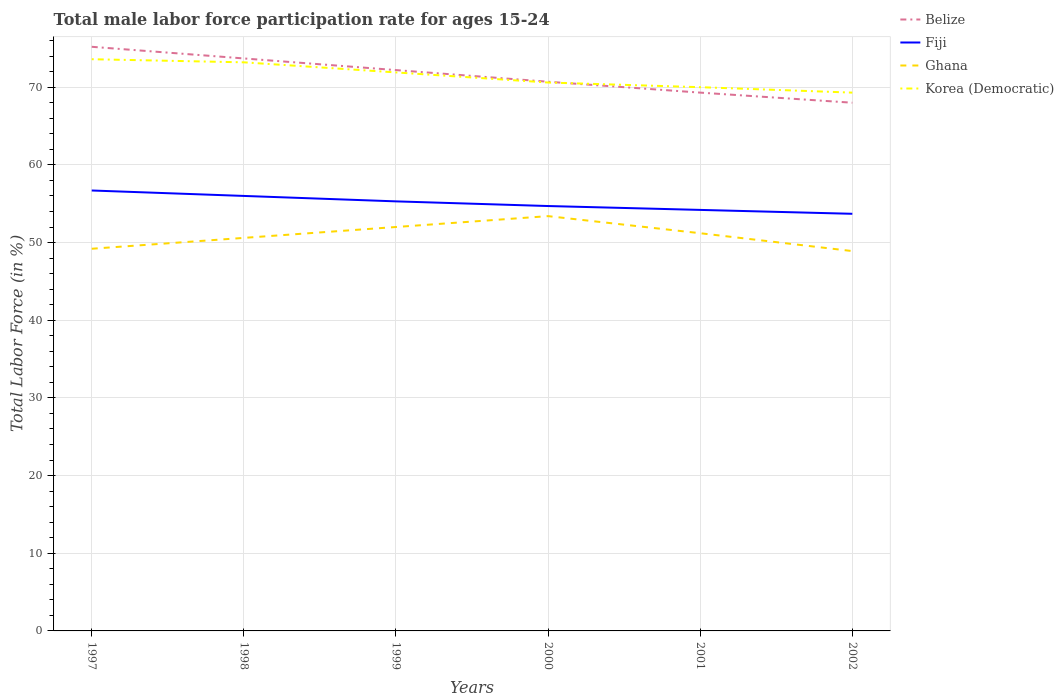How many different coloured lines are there?
Make the answer very short. 4. Does the line corresponding to Ghana intersect with the line corresponding to Fiji?
Your answer should be very brief. No. Across all years, what is the maximum male labor force participation rate in Belize?
Keep it short and to the point. 68. What is the total male labor force participation rate in Fiji in the graph?
Your answer should be very brief. 2. What is the difference between the highest and the lowest male labor force participation rate in Fiji?
Your answer should be very brief. 3. Is the male labor force participation rate in Belize strictly greater than the male labor force participation rate in Korea (Democratic) over the years?
Offer a terse response. No. What is the difference between two consecutive major ticks on the Y-axis?
Keep it short and to the point. 10. Are the values on the major ticks of Y-axis written in scientific E-notation?
Provide a short and direct response. No. Does the graph contain any zero values?
Give a very brief answer. No. Does the graph contain grids?
Make the answer very short. Yes. How many legend labels are there?
Provide a short and direct response. 4. What is the title of the graph?
Offer a terse response. Total male labor force participation rate for ages 15-24. Does "Slovak Republic" appear as one of the legend labels in the graph?
Your response must be concise. No. What is the label or title of the X-axis?
Ensure brevity in your answer.  Years. What is the Total Labor Force (in %) of Belize in 1997?
Provide a short and direct response. 75.2. What is the Total Labor Force (in %) of Fiji in 1997?
Your answer should be very brief. 56.7. What is the Total Labor Force (in %) of Ghana in 1997?
Make the answer very short. 49.2. What is the Total Labor Force (in %) of Korea (Democratic) in 1997?
Your response must be concise. 73.6. What is the Total Labor Force (in %) in Belize in 1998?
Your response must be concise. 73.7. What is the Total Labor Force (in %) in Fiji in 1998?
Your answer should be compact. 56. What is the Total Labor Force (in %) in Ghana in 1998?
Offer a terse response. 50.6. What is the Total Labor Force (in %) in Korea (Democratic) in 1998?
Your answer should be compact. 73.2. What is the Total Labor Force (in %) in Belize in 1999?
Ensure brevity in your answer.  72.2. What is the Total Labor Force (in %) in Fiji in 1999?
Your answer should be compact. 55.3. What is the Total Labor Force (in %) in Ghana in 1999?
Offer a very short reply. 52. What is the Total Labor Force (in %) of Korea (Democratic) in 1999?
Keep it short and to the point. 71.9. What is the Total Labor Force (in %) in Belize in 2000?
Provide a succinct answer. 70.7. What is the Total Labor Force (in %) of Fiji in 2000?
Give a very brief answer. 54.7. What is the Total Labor Force (in %) in Ghana in 2000?
Your response must be concise. 53.4. What is the Total Labor Force (in %) of Korea (Democratic) in 2000?
Ensure brevity in your answer.  70.6. What is the Total Labor Force (in %) in Belize in 2001?
Your answer should be very brief. 69.3. What is the Total Labor Force (in %) of Fiji in 2001?
Provide a succinct answer. 54.2. What is the Total Labor Force (in %) of Ghana in 2001?
Keep it short and to the point. 51.2. What is the Total Labor Force (in %) of Fiji in 2002?
Your answer should be compact. 53.7. What is the Total Labor Force (in %) in Ghana in 2002?
Your response must be concise. 48.9. What is the Total Labor Force (in %) of Korea (Democratic) in 2002?
Keep it short and to the point. 69.3. Across all years, what is the maximum Total Labor Force (in %) in Belize?
Your answer should be very brief. 75.2. Across all years, what is the maximum Total Labor Force (in %) of Fiji?
Provide a succinct answer. 56.7. Across all years, what is the maximum Total Labor Force (in %) of Ghana?
Offer a very short reply. 53.4. Across all years, what is the maximum Total Labor Force (in %) of Korea (Democratic)?
Keep it short and to the point. 73.6. Across all years, what is the minimum Total Labor Force (in %) of Belize?
Offer a terse response. 68. Across all years, what is the minimum Total Labor Force (in %) in Fiji?
Your response must be concise. 53.7. Across all years, what is the minimum Total Labor Force (in %) in Ghana?
Make the answer very short. 48.9. Across all years, what is the minimum Total Labor Force (in %) in Korea (Democratic)?
Give a very brief answer. 69.3. What is the total Total Labor Force (in %) in Belize in the graph?
Keep it short and to the point. 429.1. What is the total Total Labor Force (in %) of Fiji in the graph?
Provide a short and direct response. 330.6. What is the total Total Labor Force (in %) in Ghana in the graph?
Your response must be concise. 305.3. What is the total Total Labor Force (in %) of Korea (Democratic) in the graph?
Provide a short and direct response. 428.6. What is the difference between the Total Labor Force (in %) in Belize in 1997 and that in 1998?
Your answer should be very brief. 1.5. What is the difference between the Total Labor Force (in %) of Ghana in 1997 and that in 1998?
Provide a succinct answer. -1.4. What is the difference between the Total Labor Force (in %) of Korea (Democratic) in 1997 and that in 1999?
Give a very brief answer. 1.7. What is the difference between the Total Labor Force (in %) in Belize in 1997 and that in 2000?
Your answer should be very brief. 4.5. What is the difference between the Total Labor Force (in %) of Fiji in 1997 and that in 2000?
Keep it short and to the point. 2. What is the difference between the Total Labor Force (in %) in Ghana in 1997 and that in 2000?
Provide a succinct answer. -4.2. What is the difference between the Total Labor Force (in %) of Korea (Democratic) in 1997 and that in 2000?
Your answer should be very brief. 3. What is the difference between the Total Labor Force (in %) in Belize in 1997 and that in 2001?
Ensure brevity in your answer.  5.9. What is the difference between the Total Labor Force (in %) of Fiji in 1997 and that in 2001?
Provide a succinct answer. 2.5. What is the difference between the Total Labor Force (in %) of Belize in 1997 and that in 2002?
Your response must be concise. 7.2. What is the difference between the Total Labor Force (in %) of Ghana in 1997 and that in 2002?
Provide a succinct answer. 0.3. What is the difference between the Total Labor Force (in %) in Belize in 1998 and that in 2000?
Make the answer very short. 3. What is the difference between the Total Labor Force (in %) in Fiji in 1998 and that in 2000?
Provide a short and direct response. 1.3. What is the difference between the Total Labor Force (in %) of Korea (Democratic) in 1998 and that in 2000?
Your answer should be compact. 2.6. What is the difference between the Total Labor Force (in %) of Belize in 1998 and that in 2002?
Make the answer very short. 5.7. What is the difference between the Total Labor Force (in %) in Ghana in 1998 and that in 2002?
Provide a short and direct response. 1.7. What is the difference between the Total Labor Force (in %) of Korea (Democratic) in 1998 and that in 2002?
Ensure brevity in your answer.  3.9. What is the difference between the Total Labor Force (in %) of Belize in 1999 and that in 2000?
Give a very brief answer. 1.5. What is the difference between the Total Labor Force (in %) of Korea (Democratic) in 1999 and that in 2000?
Offer a very short reply. 1.3. What is the difference between the Total Labor Force (in %) in Ghana in 1999 and that in 2001?
Your answer should be very brief. 0.8. What is the difference between the Total Labor Force (in %) of Korea (Democratic) in 1999 and that in 2001?
Keep it short and to the point. 1.9. What is the difference between the Total Labor Force (in %) of Ghana in 2000 and that in 2001?
Provide a succinct answer. 2.2. What is the difference between the Total Labor Force (in %) of Korea (Democratic) in 2000 and that in 2001?
Your answer should be very brief. 0.6. What is the difference between the Total Labor Force (in %) of Belize in 2000 and that in 2002?
Offer a very short reply. 2.7. What is the difference between the Total Labor Force (in %) in Ghana in 2000 and that in 2002?
Make the answer very short. 4.5. What is the difference between the Total Labor Force (in %) of Belize in 2001 and that in 2002?
Keep it short and to the point. 1.3. What is the difference between the Total Labor Force (in %) in Fiji in 2001 and that in 2002?
Provide a succinct answer. 0.5. What is the difference between the Total Labor Force (in %) in Belize in 1997 and the Total Labor Force (in %) in Fiji in 1998?
Your answer should be compact. 19.2. What is the difference between the Total Labor Force (in %) in Belize in 1997 and the Total Labor Force (in %) in Ghana in 1998?
Give a very brief answer. 24.6. What is the difference between the Total Labor Force (in %) in Belize in 1997 and the Total Labor Force (in %) in Korea (Democratic) in 1998?
Offer a very short reply. 2. What is the difference between the Total Labor Force (in %) of Fiji in 1997 and the Total Labor Force (in %) of Ghana in 1998?
Keep it short and to the point. 6.1. What is the difference between the Total Labor Force (in %) in Fiji in 1997 and the Total Labor Force (in %) in Korea (Democratic) in 1998?
Give a very brief answer. -16.5. What is the difference between the Total Labor Force (in %) of Belize in 1997 and the Total Labor Force (in %) of Fiji in 1999?
Offer a very short reply. 19.9. What is the difference between the Total Labor Force (in %) of Belize in 1997 and the Total Labor Force (in %) of Ghana in 1999?
Ensure brevity in your answer.  23.2. What is the difference between the Total Labor Force (in %) of Belize in 1997 and the Total Labor Force (in %) of Korea (Democratic) in 1999?
Your response must be concise. 3.3. What is the difference between the Total Labor Force (in %) of Fiji in 1997 and the Total Labor Force (in %) of Ghana in 1999?
Provide a short and direct response. 4.7. What is the difference between the Total Labor Force (in %) of Fiji in 1997 and the Total Labor Force (in %) of Korea (Democratic) in 1999?
Provide a succinct answer. -15.2. What is the difference between the Total Labor Force (in %) of Ghana in 1997 and the Total Labor Force (in %) of Korea (Democratic) in 1999?
Give a very brief answer. -22.7. What is the difference between the Total Labor Force (in %) of Belize in 1997 and the Total Labor Force (in %) of Ghana in 2000?
Your response must be concise. 21.8. What is the difference between the Total Labor Force (in %) in Ghana in 1997 and the Total Labor Force (in %) in Korea (Democratic) in 2000?
Provide a succinct answer. -21.4. What is the difference between the Total Labor Force (in %) in Belize in 1997 and the Total Labor Force (in %) in Ghana in 2001?
Your answer should be compact. 24. What is the difference between the Total Labor Force (in %) in Belize in 1997 and the Total Labor Force (in %) in Korea (Democratic) in 2001?
Keep it short and to the point. 5.2. What is the difference between the Total Labor Force (in %) in Fiji in 1997 and the Total Labor Force (in %) in Ghana in 2001?
Your answer should be compact. 5.5. What is the difference between the Total Labor Force (in %) of Ghana in 1997 and the Total Labor Force (in %) of Korea (Democratic) in 2001?
Ensure brevity in your answer.  -20.8. What is the difference between the Total Labor Force (in %) of Belize in 1997 and the Total Labor Force (in %) of Ghana in 2002?
Provide a succinct answer. 26.3. What is the difference between the Total Labor Force (in %) in Belize in 1997 and the Total Labor Force (in %) in Korea (Democratic) in 2002?
Your answer should be very brief. 5.9. What is the difference between the Total Labor Force (in %) of Fiji in 1997 and the Total Labor Force (in %) of Ghana in 2002?
Offer a terse response. 7.8. What is the difference between the Total Labor Force (in %) of Fiji in 1997 and the Total Labor Force (in %) of Korea (Democratic) in 2002?
Make the answer very short. -12.6. What is the difference between the Total Labor Force (in %) in Ghana in 1997 and the Total Labor Force (in %) in Korea (Democratic) in 2002?
Offer a terse response. -20.1. What is the difference between the Total Labor Force (in %) of Belize in 1998 and the Total Labor Force (in %) of Fiji in 1999?
Give a very brief answer. 18.4. What is the difference between the Total Labor Force (in %) in Belize in 1998 and the Total Labor Force (in %) in Ghana in 1999?
Your response must be concise. 21.7. What is the difference between the Total Labor Force (in %) in Fiji in 1998 and the Total Labor Force (in %) in Ghana in 1999?
Your answer should be very brief. 4. What is the difference between the Total Labor Force (in %) of Fiji in 1998 and the Total Labor Force (in %) of Korea (Democratic) in 1999?
Offer a very short reply. -15.9. What is the difference between the Total Labor Force (in %) in Ghana in 1998 and the Total Labor Force (in %) in Korea (Democratic) in 1999?
Your answer should be very brief. -21.3. What is the difference between the Total Labor Force (in %) of Belize in 1998 and the Total Labor Force (in %) of Fiji in 2000?
Offer a very short reply. 19. What is the difference between the Total Labor Force (in %) in Belize in 1998 and the Total Labor Force (in %) in Ghana in 2000?
Make the answer very short. 20.3. What is the difference between the Total Labor Force (in %) of Fiji in 1998 and the Total Labor Force (in %) of Ghana in 2000?
Give a very brief answer. 2.6. What is the difference between the Total Labor Force (in %) of Fiji in 1998 and the Total Labor Force (in %) of Korea (Democratic) in 2000?
Give a very brief answer. -14.6. What is the difference between the Total Labor Force (in %) of Belize in 1998 and the Total Labor Force (in %) of Korea (Democratic) in 2001?
Keep it short and to the point. 3.7. What is the difference between the Total Labor Force (in %) in Fiji in 1998 and the Total Labor Force (in %) in Ghana in 2001?
Make the answer very short. 4.8. What is the difference between the Total Labor Force (in %) in Fiji in 1998 and the Total Labor Force (in %) in Korea (Democratic) in 2001?
Give a very brief answer. -14. What is the difference between the Total Labor Force (in %) of Ghana in 1998 and the Total Labor Force (in %) of Korea (Democratic) in 2001?
Offer a very short reply. -19.4. What is the difference between the Total Labor Force (in %) of Belize in 1998 and the Total Labor Force (in %) of Fiji in 2002?
Give a very brief answer. 20. What is the difference between the Total Labor Force (in %) in Belize in 1998 and the Total Labor Force (in %) in Ghana in 2002?
Make the answer very short. 24.8. What is the difference between the Total Labor Force (in %) in Ghana in 1998 and the Total Labor Force (in %) in Korea (Democratic) in 2002?
Your response must be concise. -18.7. What is the difference between the Total Labor Force (in %) of Belize in 1999 and the Total Labor Force (in %) of Fiji in 2000?
Make the answer very short. 17.5. What is the difference between the Total Labor Force (in %) in Belize in 1999 and the Total Labor Force (in %) in Ghana in 2000?
Give a very brief answer. 18.8. What is the difference between the Total Labor Force (in %) of Belize in 1999 and the Total Labor Force (in %) of Korea (Democratic) in 2000?
Provide a short and direct response. 1.6. What is the difference between the Total Labor Force (in %) of Fiji in 1999 and the Total Labor Force (in %) of Ghana in 2000?
Provide a short and direct response. 1.9. What is the difference between the Total Labor Force (in %) of Fiji in 1999 and the Total Labor Force (in %) of Korea (Democratic) in 2000?
Make the answer very short. -15.3. What is the difference between the Total Labor Force (in %) in Ghana in 1999 and the Total Labor Force (in %) in Korea (Democratic) in 2000?
Make the answer very short. -18.6. What is the difference between the Total Labor Force (in %) in Belize in 1999 and the Total Labor Force (in %) in Korea (Democratic) in 2001?
Keep it short and to the point. 2.2. What is the difference between the Total Labor Force (in %) of Fiji in 1999 and the Total Labor Force (in %) of Ghana in 2001?
Offer a terse response. 4.1. What is the difference between the Total Labor Force (in %) of Fiji in 1999 and the Total Labor Force (in %) of Korea (Democratic) in 2001?
Make the answer very short. -14.7. What is the difference between the Total Labor Force (in %) of Belize in 1999 and the Total Labor Force (in %) of Fiji in 2002?
Keep it short and to the point. 18.5. What is the difference between the Total Labor Force (in %) in Belize in 1999 and the Total Labor Force (in %) in Ghana in 2002?
Keep it short and to the point. 23.3. What is the difference between the Total Labor Force (in %) in Belize in 1999 and the Total Labor Force (in %) in Korea (Democratic) in 2002?
Make the answer very short. 2.9. What is the difference between the Total Labor Force (in %) of Fiji in 1999 and the Total Labor Force (in %) of Ghana in 2002?
Offer a very short reply. 6.4. What is the difference between the Total Labor Force (in %) in Ghana in 1999 and the Total Labor Force (in %) in Korea (Democratic) in 2002?
Make the answer very short. -17.3. What is the difference between the Total Labor Force (in %) in Belize in 2000 and the Total Labor Force (in %) in Fiji in 2001?
Your answer should be compact. 16.5. What is the difference between the Total Labor Force (in %) in Fiji in 2000 and the Total Labor Force (in %) in Korea (Democratic) in 2001?
Your answer should be compact. -15.3. What is the difference between the Total Labor Force (in %) in Ghana in 2000 and the Total Labor Force (in %) in Korea (Democratic) in 2001?
Your response must be concise. -16.6. What is the difference between the Total Labor Force (in %) of Belize in 2000 and the Total Labor Force (in %) of Ghana in 2002?
Keep it short and to the point. 21.8. What is the difference between the Total Labor Force (in %) of Fiji in 2000 and the Total Labor Force (in %) of Ghana in 2002?
Keep it short and to the point. 5.8. What is the difference between the Total Labor Force (in %) of Fiji in 2000 and the Total Labor Force (in %) of Korea (Democratic) in 2002?
Your answer should be compact. -14.6. What is the difference between the Total Labor Force (in %) in Ghana in 2000 and the Total Labor Force (in %) in Korea (Democratic) in 2002?
Your response must be concise. -15.9. What is the difference between the Total Labor Force (in %) in Belize in 2001 and the Total Labor Force (in %) in Ghana in 2002?
Keep it short and to the point. 20.4. What is the difference between the Total Labor Force (in %) of Fiji in 2001 and the Total Labor Force (in %) of Ghana in 2002?
Provide a succinct answer. 5.3. What is the difference between the Total Labor Force (in %) in Fiji in 2001 and the Total Labor Force (in %) in Korea (Democratic) in 2002?
Keep it short and to the point. -15.1. What is the difference between the Total Labor Force (in %) of Ghana in 2001 and the Total Labor Force (in %) of Korea (Democratic) in 2002?
Provide a short and direct response. -18.1. What is the average Total Labor Force (in %) in Belize per year?
Ensure brevity in your answer.  71.52. What is the average Total Labor Force (in %) of Fiji per year?
Offer a very short reply. 55.1. What is the average Total Labor Force (in %) in Ghana per year?
Ensure brevity in your answer.  50.88. What is the average Total Labor Force (in %) of Korea (Democratic) per year?
Your answer should be very brief. 71.43. In the year 1997, what is the difference between the Total Labor Force (in %) in Belize and Total Labor Force (in %) in Fiji?
Offer a terse response. 18.5. In the year 1997, what is the difference between the Total Labor Force (in %) of Belize and Total Labor Force (in %) of Ghana?
Offer a very short reply. 26. In the year 1997, what is the difference between the Total Labor Force (in %) in Belize and Total Labor Force (in %) in Korea (Democratic)?
Provide a short and direct response. 1.6. In the year 1997, what is the difference between the Total Labor Force (in %) in Fiji and Total Labor Force (in %) in Korea (Democratic)?
Ensure brevity in your answer.  -16.9. In the year 1997, what is the difference between the Total Labor Force (in %) in Ghana and Total Labor Force (in %) in Korea (Democratic)?
Ensure brevity in your answer.  -24.4. In the year 1998, what is the difference between the Total Labor Force (in %) in Belize and Total Labor Force (in %) in Fiji?
Offer a very short reply. 17.7. In the year 1998, what is the difference between the Total Labor Force (in %) of Belize and Total Labor Force (in %) of Ghana?
Keep it short and to the point. 23.1. In the year 1998, what is the difference between the Total Labor Force (in %) in Fiji and Total Labor Force (in %) in Ghana?
Give a very brief answer. 5.4. In the year 1998, what is the difference between the Total Labor Force (in %) in Fiji and Total Labor Force (in %) in Korea (Democratic)?
Your response must be concise. -17.2. In the year 1998, what is the difference between the Total Labor Force (in %) of Ghana and Total Labor Force (in %) of Korea (Democratic)?
Offer a terse response. -22.6. In the year 1999, what is the difference between the Total Labor Force (in %) of Belize and Total Labor Force (in %) of Ghana?
Offer a terse response. 20.2. In the year 1999, what is the difference between the Total Labor Force (in %) in Fiji and Total Labor Force (in %) in Korea (Democratic)?
Give a very brief answer. -16.6. In the year 1999, what is the difference between the Total Labor Force (in %) in Ghana and Total Labor Force (in %) in Korea (Democratic)?
Provide a short and direct response. -19.9. In the year 2000, what is the difference between the Total Labor Force (in %) of Belize and Total Labor Force (in %) of Fiji?
Offer a terse response. 16. In the year 2000, what is the difference between the Total Labor Force (in %) in Fiji and Total Labor Force (in %) in Korea (Democratic)?
Your response must be concise. -15.9. In the year 2000, what is the difference between the Total Labor Force (in %) of Ghana and Total Labor Force (in %) of Korea (Democratic)?
Your answer should be very brief. -17.2. In the year 2001, what is the difference between the Total Labor Force (in %) in Belize and Total Labor Force (in %) in Fiji?
Make the answer very short. 15.1. In the year 2001, what is the difference between the Total Labor Force (in %) of Belize and Total Labor Force (in %) of Ghana?
Offer a very short reply. 18.1. In the year 2001, what is the difference between the Total Labor Force (in %) in Belize and Total Labor Force (in %) in Korea (Democratic)?
Offer a terse response. -0.7. In the year 2001, what is the difference between the Total Labor Force (in %) of Fiji and Total Labor Force (in %) of Ghana?
Your response must be concise. 3. In the year 2001, what is the difference between the Total Labor Force (in %) of Fiji and Total Labor Force (in %) of Korea (Democratic)?
Ensure brevity in your answer.  -15.8. In the year 2001, what is the difference between the Total Labor Force (in %) of Ghana and Total Labor Force (in %) of Korea (Democratic)?
Provide a short and direct response. -18.8. In the year 2002, what is the difference between the Total Labor Force (in %) in Belize and Total Labor Force (in %) in Ghana?
Offer a terse response. 19.1. In the year 2002, what is the difference between the Total Labor Force (in %) in Belize and Total Labor Force (in %) in Korea (Democratic)?
Your answer should be compact. -1.3. In the year 2002, what is the difference between the Total Labor Force (in %) in Fiji and Total Labor Force (in %) in Korea (Democratic)?
Offer a very short reply. -15.6. In the year 2002, what is the difference between the Total Labor Force (in %) of Ghana and Total Labor Force (in %) of Korea (Democratic)?
Offer a terse response. -20.4. What is the ratio of the Total Labor Force (in %) in Belize in 1997 to that in 1998?
Ensure brevity in your answer.  1.02. What is the ratio of the Total Labor Force (in %) of Fiji in 1997 to that in 1998?
Give a very brief answer. 1.01. What is the ratio of the Total Labor Force (in %) of Ghana in 1997 to that in 1998?
Offer a terse response. 0.97. What is the ratio of the Total Labor Force (in %) in Belize in 1997 to that in 1999?
Give a very brief answer. 1.04. What is the ratio of the Total Labor Force (in %) of Fiji in 1997 to that in 1999?
Your answer should be very brief. 1.03. What is the ratio of the Total Labor Force (in %) in Ghana in 1997 to that in 1999?
Make the answer very short. 0.95. What is the ratio of the Total Labor Force (in %) of Korea (Democratic) in 1997 to that in 1999?
Provide a succinct answer. 1.02. What is the ratio of the Total Labor Force (in %) of Belize in 1997 to that in 2000?
Make the answer very short. 1.06. What is the ratio of the Total Labor Force (in %) of Fiji in 1997 to that in 2000?
Keep it short and to the point. 1.04. What is the ratio of the Total Labor Force (in %) of Ghana in 1997 to that in 2000?
Offer a very short reply. 0.92. What is the ratio of the Total Labor Force (in %) in Korea (Democratic) in 1997 to that in 2000?
Keep it short and to the point. 1.04. What is the ratio of the Total Labor Force (in %) of Belize in 1997 to that in 2001?
Offer a terse response. 1.09. What is the ratio of the Total Labor Force (in %) of Fiji in 1997 to that in 2001?
Make the answer very short. 1.05. What is the ratio of the Total Labor Force (in %) of Ghana in 1997 to that in 2001?
Your answer should be compact. 0.96. What is the ratio of the Total Labor Force (in %) of Korea (Democratic) in 1997 to that in 2001?
Your answer should be very brief. 1.05. What is the ratio of the Total Labor Force (in %) of Belize in 1997 to that in 2002?
Provide a short and direct response. 1.11. What is the ratio of the Total Labor Force (in %) in Fiji in 1997 to that in 2002?
Offer a very short reply. 1.06. What is the ratio of the Total Labor Force (in %) of Korea (Democratic) in 1997 to that in 2002?
Keep it short and to the point. 1.06. What is the ratio of the Total Labor Force (in %) in Belize in 1998 to that in 1999?
Provide a short and direct response. 1.02. What is the ratio of the Total Labor Force (in %) in Fiji in 1998 to that in 1999?
Keep it short and to the point. 1.01. What is the ratio of the Total Labor Force (in %) of Ghana in 1998 to that in 1999?
Your answer should be compact. 0.97. What is the ratio of the Total Labor Force (in %) of Korea (Democratic) in 1998 to that in 1999?
Your answer should be compact. 1.02. What is the ratio of the Total Labor Force (in %) of Belize in 1998 to that in 2000?
Offer a terse response. 1.04. What is the ratio of the Total Labor Force (in %) of Fiji in 1998 to that in 2000?
Keep it short and to the point. 1.02. What is the ratio of the Total Labor Force (in %) of Ghana in 1998 to that in 2000?
Offer a very short reply. 0.95. What is the ratio of the Total Labor Force (in %) of Korea (Democratic) in 1998 to that in 2000?
Offer a very short reply. 1.04. What is the ratio of the Total Labor Force (in %) of Belize in 1998 to that in 2001?
Your answer should be very brief. 1.06. What is the ratio of the Total Labor Force (in %) in Fiji in 1998 to that in 2001?
Your answer should be compact. 1.03. What is the ratio of the Total Labor Force (in %) of Ghana in 1998 to that in 2001?
Your response must be concise. 0.99. What is the ratio of the Total Labor Force (in %) of Korea (Democratic) in 1998 to that in 2001?
Offer a terse response. 1.05. What is the ratio of the Total Labor Force (in %) in Belize in 1998 to that in 2002?
Your answer should be compact. 1.08. What is the ratio of the Total Labor Force (in %) of Fiji in 1998 to that in 2002?
Keep it short and to the point. 1.04. What is the ratio of the Total Labor Force (in %) of Ghana in 1998 to that in 2002?
Provide a succinct answer. 1.03. What is the ratio of the Total Labor Force (in %) of Korea (Democratic) in 1998 to that in 2002?
Provide a short and direct response. 1.06. What is the ratio of the Total Labor Force (in %) in Belize in 1999 to that in 2000?
Ensure brevity in your answer.  1.02. What is the ratio of the Total Labor Force (in %) in Fiji in 1999 to that in 2000?
Provide a short and direct response. 1.01. What is the ratio of the Total Labor Force (in %) in Ghana in 1999 to that in 2000?
Your answer should be compact. 0.97. What is the ratio of the Total Labor Force (in %) in Korea (Democratic) in 1999 to that in 2000?
Your answer should be compact. 1.02. What is the ratio of the Total Labor Force (in %) in Belize in 1999 to that in 2001?
Provide a short and direct response. 1.04. What is the ratio of the Total Labor Force (in %) of Fiji in 1999 to that in 2001?
Provide a succinct answer. 1.02. What is the ratio of the Total Labor Force (in %) in Ghana in 1999 to that in 2001?
Keep it short and to the point. 1.02. What is the ratio of the Total Labor Force (in %) of Korea (Democratic) in 1999 to that in 2001?
Your answer should be compact. 1.03. What is the ratio of the Total Labor Force (in %) of Belize in 1999 to that in 2002?
Ensure brevity in your answer.  1.06. What is the ratio of the Total Labor Force (in %) of Fiji in 1999 to that in 2002?
Your answer should be compact. 1.03. What is the ratio of the Total Labor Force (in %) in Ghana in 1999 to that in 2002?
Offer a terse response. 1.06. What is the ratio of the Total Labor Force (in %) in Korea (Democratic) in 1999 to that in 2002?
Provide a short and direct response. 1.04. What is the ratio of the Total Labor Force (in %) of Belize in 2000 to that in 2001?
Give a very brief answer. 1.02. What is the ratio of the Total Labor Force (in %) of Fiji in 2000 to that in 2001?
Offer a terse response. 1.01. What is the ratio of the Total Labor Force (in %) of Ghana in 2000 to that in 2001?
Your response must be concise. 1.04. What is the ratio of the Total Labor Force (in %) in Korea (Democratic) in 2000 to that in 2001?
Your answer should be compact. 1.01. What is the ratio of the Total Labor Force (in %) in Belize in 2000 to that in 2002?
Your response must be concise. 1.04. What is the ratio of the Total Labor Force (in %) of Fiji in 2000 to that in 2002?
Give a very brief answer. 1.02. What is the ratio of the Total Labor Force (in %) of Ghana in 2000 to that in 2002?
Ensure brevity in your answer.  1.09. What is the ratio of the Total Labor Force (in %) in Korea (Democratic) in 2000 to that in 2002?
Keep it short and to the point. 1.02. What is the ratio of the Total Labor Force (in %) of Belize in 2001 to that in 2002?
Offer a very short reply. 1.02. What is the ratio of the Total Labor Force (in %) in Fiji in 2001 to that in 2002?
Make the answer very short. 1.01. What is the ratio of the Total Labor Force (in %) in Ghana in 2001 to that in 2002?
Make the answer very short. 1.05. What is the difference between the highest and the second highest Total Labor Force (in %) in Belize?
Offer a very short reply. 1.5. What is the difference between the highest and the second highest Total Labor Force (in %) in Ghana?
Offer a very short reply. 1.4. What is the difference between the highest and the lowest Total Labor Force (in %) of Fiji?
Give a very brief answer. 3. What is the difference between the highest and the lowest Total Labor Force (in %) in Korea (Democratic)?
Ensure brevity in your answer.  4.3. 